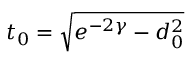Convert formula to latex. <formula><loc_0><loc_0><loc_500><loc_500>t _ { 0 } = \sqrt { e ^ { - 2 \gamma } - d _ { 0 } ^ { 2 } }</formula> 